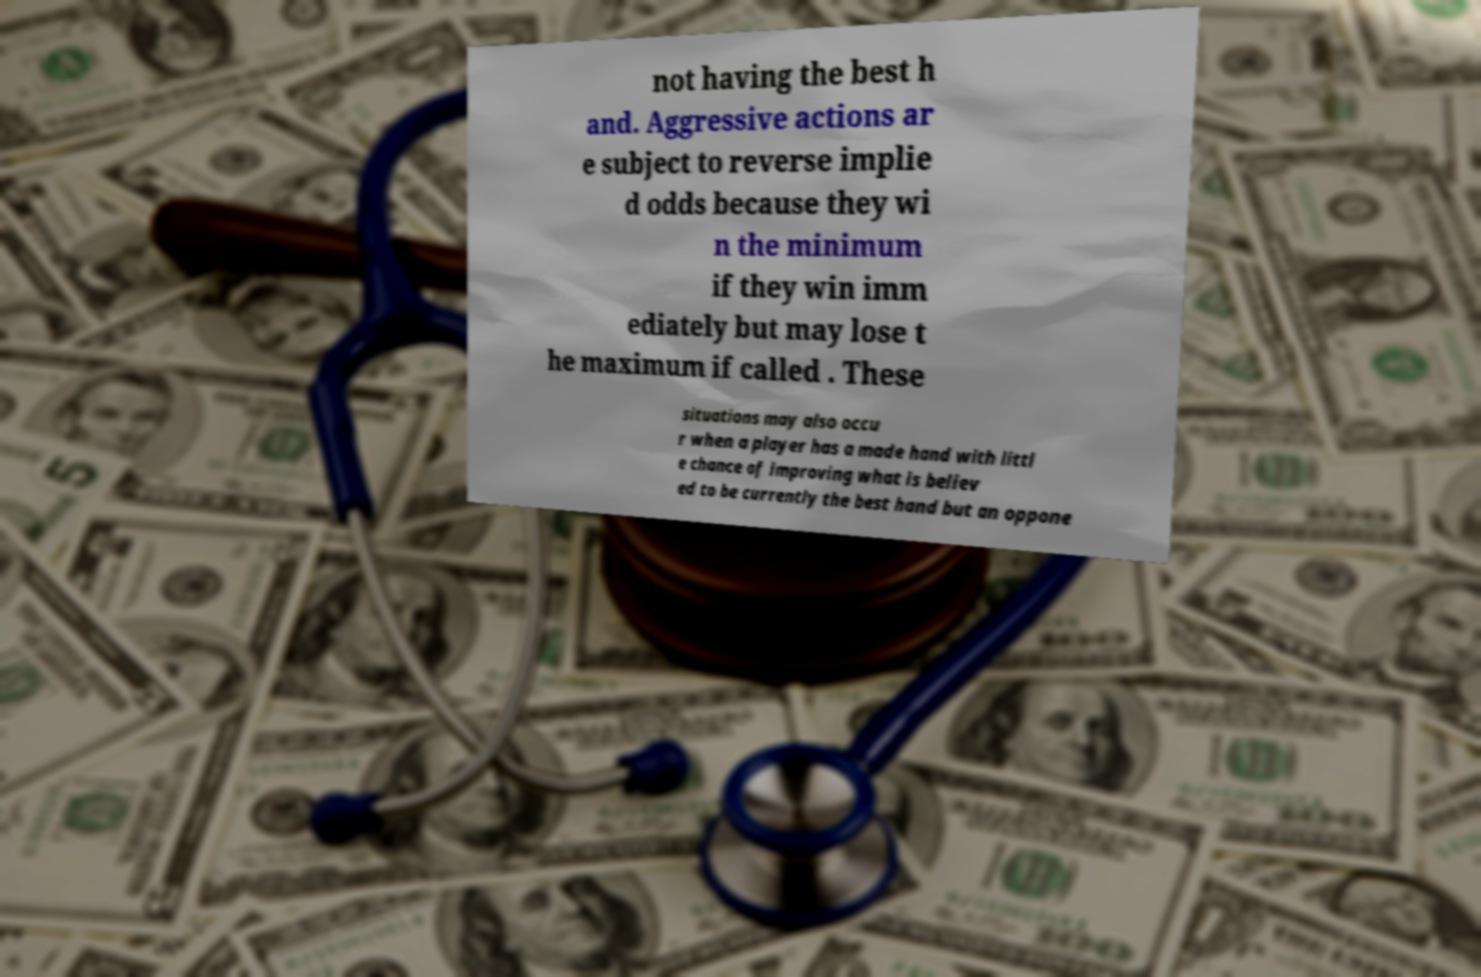Please read and relay the text visible in this image. What does it say? not having the best h and. Aggressive actions ar e subject to reverse implie d odds because they wi n the minimum if they win imm ediately but may lose t he maximum if called . These situations may also occu r when a player has a made hand with littl e chance of improving what is believ ed to be currently the best hand but an oppone 